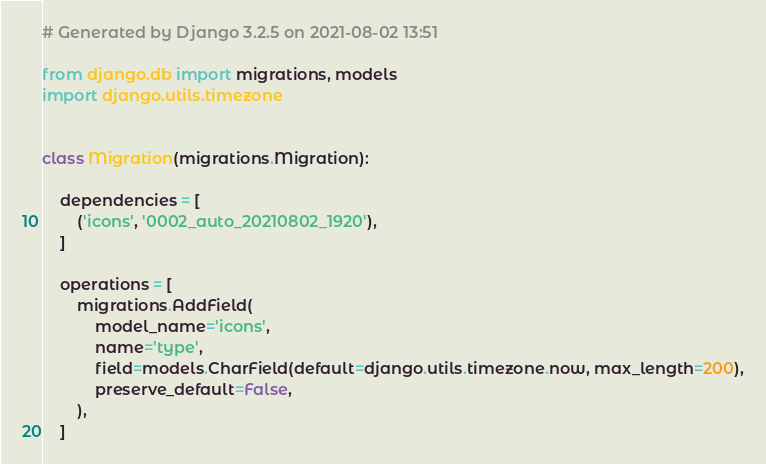<code> <loc_0><loc_0><loc_500><loc_500><_Python_># Generated by Django 3.2.5 on 2021-08-02 13:51

from django.db import migrations, models
import django.utils.timezone


class Migration(migrations.Migration):

    dependencies = [
        ('icons', '0002_auto_20210802_1920'),
    ]

    operations = [
        migrations.AddField(
            model_name='icons',
            name='type',
            field=models.CharField(default=django.utils.timezone.now, max_length=200),
            preserve_default=False,
        ),
    ]
</code> 